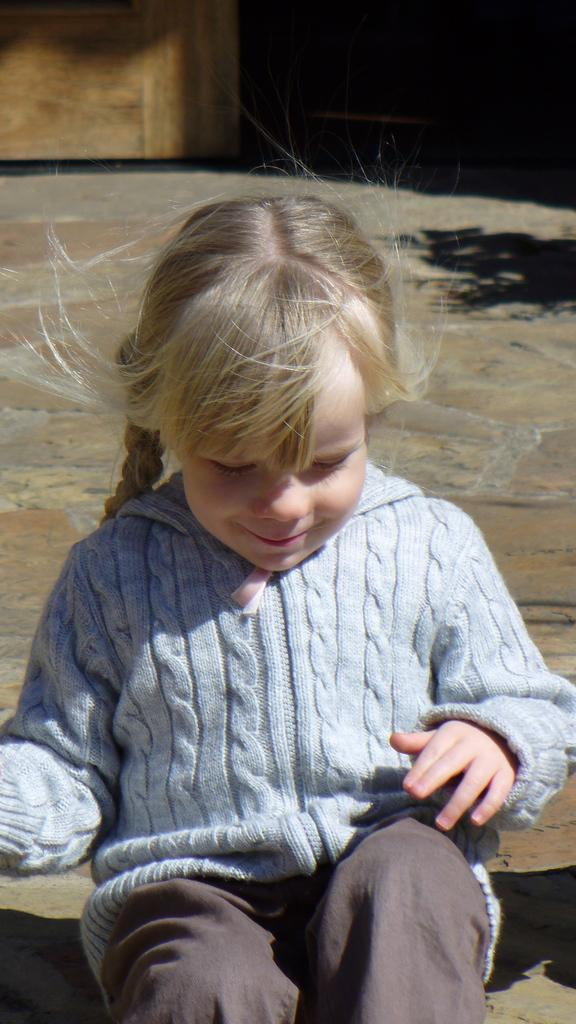What is the main subject of the image? The main subject of the image is a girl. What is the girl doing in the image? The girl is sitting in the image. What is the facial expression of the girl? The girl is smiling in the image. What color is the girl's t-shirt? The girl is wearing a blue t-shirt in the image. What type of clothing is the girl wearing on her lower body? The girl is wearing pants in the image. What type of frame is surrounding the girl in the image? There is no frame surrounding the girl in the image. What type of bushes can be seen behind the girl in the image? There is no mention of bushes in the provided facts, so we cannot determine if they are present in the image. --- Facts: 1. There is a car in the image. 2. The car is red. 3. The car has four wheels. 4. The car has a license plate. 5. The car is parked on the street. Absurd Topics: parrot, sand, ocean Conversation: What is the main subject of the image? The main subject of the image is a car. What color is the car? The car is red. How many wheels does the car have? The car has four wheels. Does the car have any identifying features? Yes, the car has a license plate. Where is the car located in the image? The car is parked on the street in the image. Reasoning: Let's think step by step in order to produce the conversation. We start by identifying the main subject of the image, which is the car. Then, we describe the car's color, number of wheels, and the presence of a license plate. Finally, we describe the car's location in the image, which is parked on the street. Each question is designed to elicit a specific detail about the image that is known from the provided facts. Absurd Question/Answer: Can you tell me how many parrots are sitting on the car in the image? There is no mention of parrots in the provided facts, so we cannot determine if they are present in the image. What type of sand can be seen near the car in the image? There is no mention of sand in the provided facts, so we cannot determine if it is present in the image. --- Facts: 1. There is a dog in the image. 2. The dog is brown. 3. The dog is sitting. 4. The dog is wearing a collar. 5. The dog is on a leash. Absurd Topics: bicycle, umbrella, rain Conversation: What is the main subject of the image? The main subject of the image is a dog. 